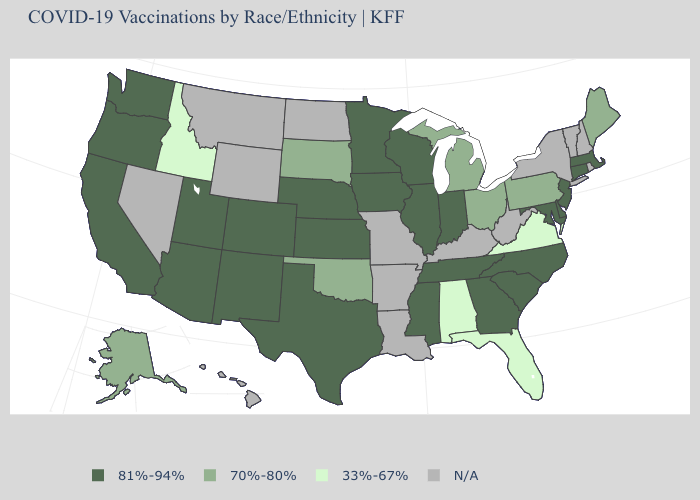Name the states that have a value in the range 33%-67%?
Keep it brief. Alabama, Florida, Idaho, Virginia. What is the highest value in states that border Minnesota?
Quick response, please. 81%-94%. What is the value of Texas?
Concise answer only. 81%-94%. Name the states that have a value in the range N/A?
Write a very short answer. Arkansas, Hawaii, Kentucky, Louisiana, Missouri, Montana, Nevada, New Hampshire, New York, North Dakota, Rhode Island, Vermont, West Virginia, Wyoming. How many symbols are there in the legend?
Give a very brief answer. 4. Name the states that have a value in the range 33%-67%?
Be succinct. Alabama, Florida, Idaho, Virginia. Among the states that border New Mexico , does Oklahoma have the lowest value?
Quick response, please. Yes. Name the states that have a value in the range 81%-94%?
Concise answer only. Arizona, California, Colorado, Connecticut, Delaware, Georgia, Illinois, Indiana, Iowa, Kansas, Maryland, Massachusetts, Minnesota, Mississippi, Nebraska, New Jersey, New Mexico, North Carolina, Oregon, South Carolina, Tennessee, Texas, Utah, Washington, Wisconsin. What is the value of Utah?
Answer briefly. 81%-94%. Does Massachusetts have the highest value in the Northeast?
Short answer required. Yes. Name the states that have a value in the range N/A?
Give a very brief answer. Arkansas, Hawaii, Kentucky, Louisiana, Missouri, Montana, Nevada, New Hampshire, New York, North Dakota, Rhode Island, Vermont, West Virginia, Wyoming. Does Massachusetts have the lowest value in the Northeast?
Keep it brief. No. Among the states that border Texas , which have the lowest value?
Keep it brief. Oklahoma. 